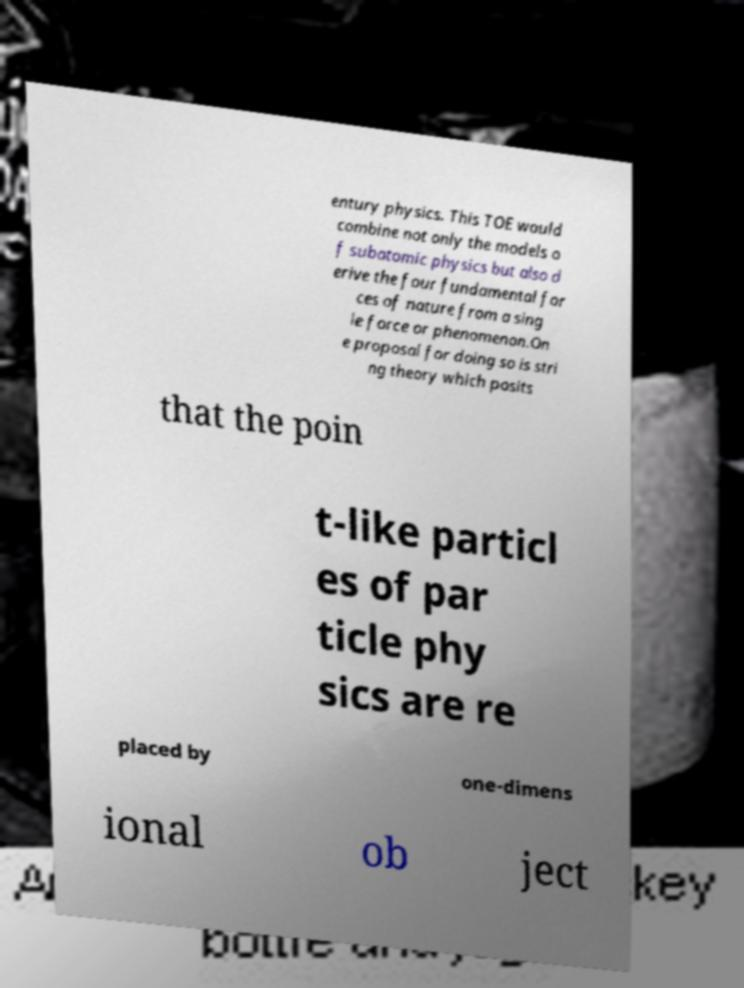For documentation purposes, I need the text within this image transcribed. Could you provide that? entury physics. This TOE would combine not only the models o f subatomic physics but also d erive the four fundamental for ces of nature from a sing le force or phenomenon.On e proposal for doing so is stri ng theory which posits that the poin t-like particl es of par ticle phy sics are re placed by one-dimens ional ob ject 